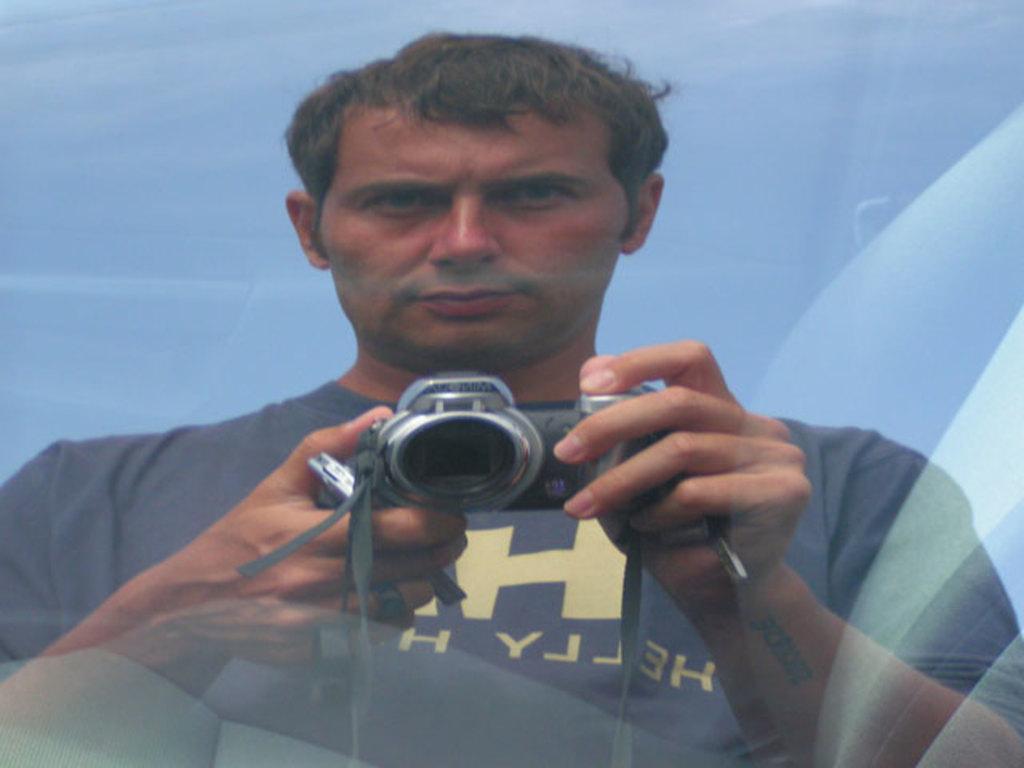In one or two sentences, can you explain what this image depicts? In this given picture, We can see a person standing and holding a camera in his hands. 